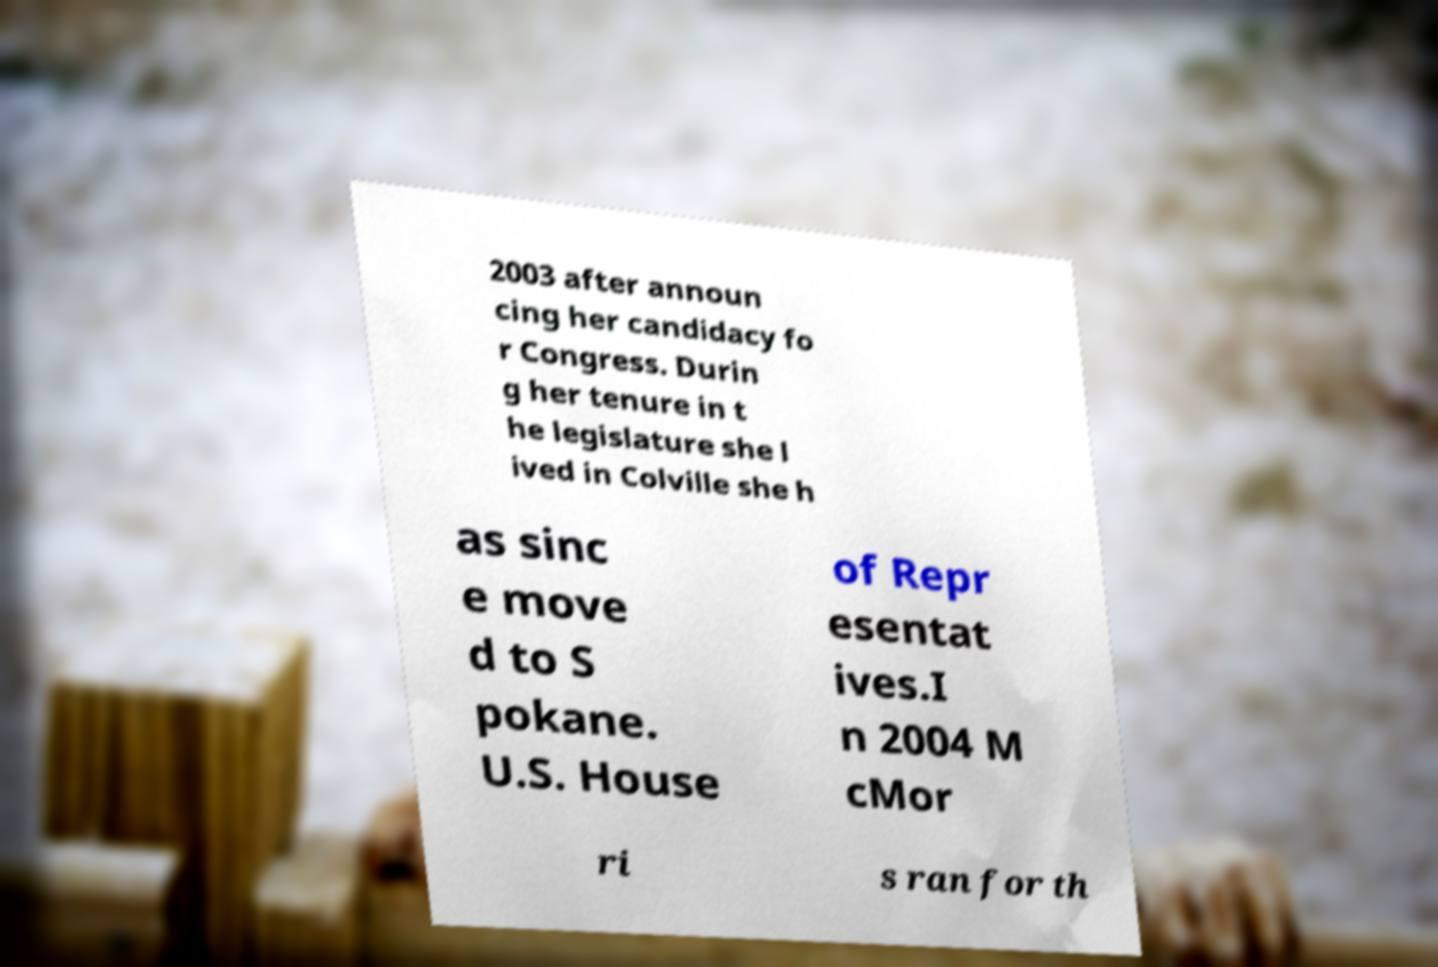What messages or text are displayed in this image? I need them in a readable, typed format. 2003 after announ cing her candidacy fo r Congress. Durin g her tenure in t he legislature she l ived in Colville she h as sinc e move d to S pokane. U.S. House of Repr esentat ives.I n 2004 M cMor ri s ran for th 